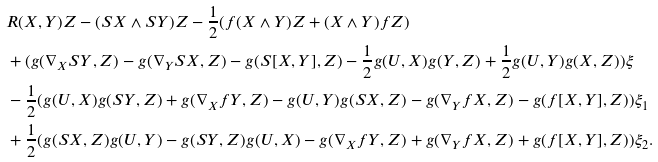<formula> <loc_0><loc_0><loc_500><loc_500>& R ( X , Y ) Z - ( S X \wedge S Y ) Z - \frac { 1 } { 2 } ( f ( X \wedge Y ) Z + ( X \wedge Y ) f Z ) \\ & + ( g ( \nabla _ { X } S Y , Z ) - g ( \nabla _ { Y } S X , Z ) - g ( S [ X , Y ] , Z ) - \frac { 1 } { 2 } g ( U , X ) g ( Y , Z ) + \frac { 1 } { 2 } g ( U , Y ) g ( X , Z ) ) \xi \\ & - \frac { 1 } { 2 } ( g ( U , X ) g ( S Y , Z ) + g ( \nabla _ { X } f Y , Z ) - g ( U , Y ) g ( S X , Z ) - g ( \nabla _ { Y } f X , Z ) - g ( f [ X , Y ] , Z ) ) \xi _ { 1 } \\ & + \frac { 1 } { 2 } ( g ( S X , Z ) g ( U , Y ) - g ( S Y , Z ) g ( U , X ) - g ( \nabla _ { X } f Y , Z ) + g ( \nabla _ { Y } f X , Z ) + g ( f [ X , Y ] , Z ) ) \xi _ { 2 } .</formula> 